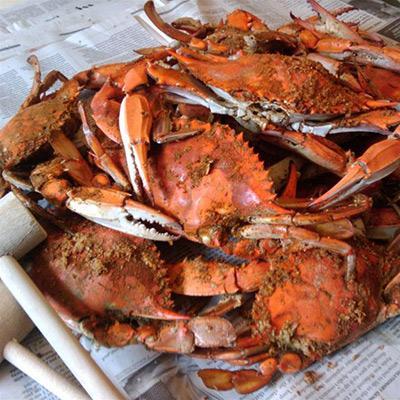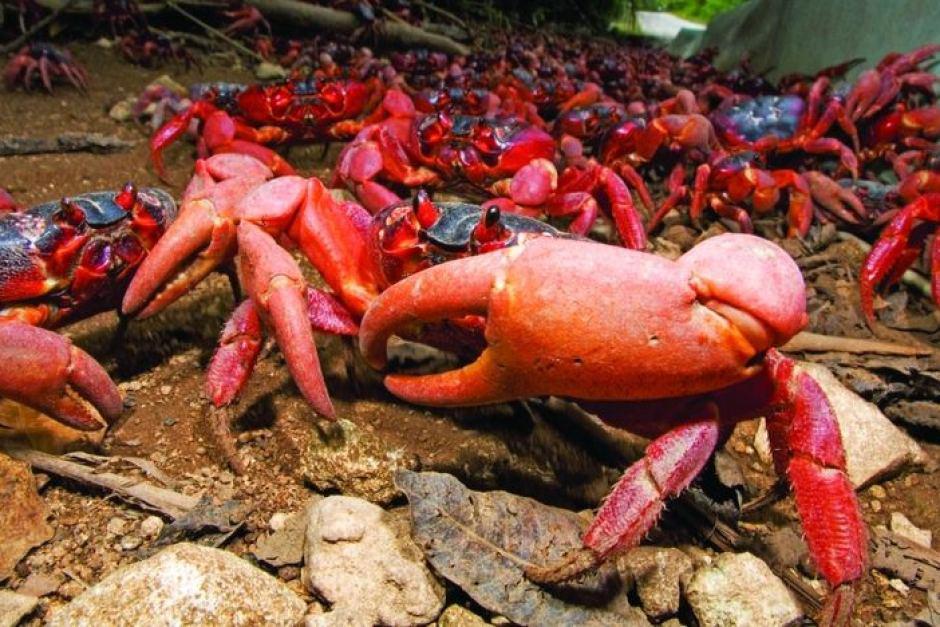The first image is the image on the left, the second image is the image on the right. Assess this claim about the two images: "The right image features a round plate containing one rightside-up crab with its red-orange shell and claws intact.". Correct or not? Answer yes or no. No. The first image is the image on the left, the second image is the image on the right. Given the left and right images, does the statement "IN at least one image there is a dead and full crab with it head intact sitting on a white plate." hold true? Answer yes or no. No. 